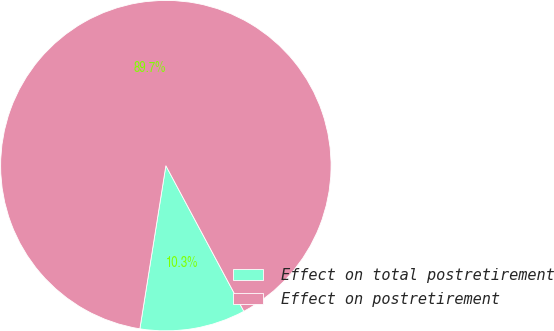Convert chart to OTSL. <chart><loc_0><loc_0><loc_500><loc_500><pie_chart><fcel>Effect on total postretirement<fcel>Effect on postretirement<nl><fcel>10.34%<fcel>89.66%<nl></chart> 